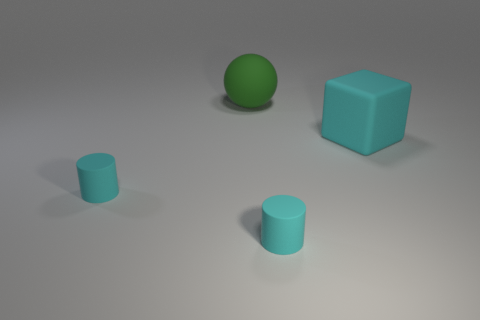There is a big rubber object behind the rubber cube; what number of cyan cylinders are in front of it?
Provide a short and direct response. 2. Is the size of the green thing the same as the object to the left of the green object?
Your response must be concise. No. Do the ball and the cube have the same size?
Your answer should be compact. Yes. Are there any gray objects of the same size as the green matte sphere?
Offer a terse response. No. There is a tiny cyan cylinder that is left of the large sphere; what is its material?
Ensure brevity in your answer.  Rubber. What color is the big sphere that is the same material as the big cyan block?
Provide a short and direct response. Green. What number of matte objects are either green things or tiny cylinders?
Provide a short and direct response. 3. There is a cyan thing that is the same size as the ball; what shape is it?
Your answer should be very brief. Cube. How many objects are things on the left side of the big cyan cube or cyan things that are to the left of the large cube?
Your answer should be compact. 3. There is a green thing that is the same size as the rubber block; what is its material?
Offer a very short reply. Rubber. 